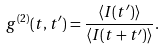Convert formula to latex. <formula><loc_0><loc_0><loc_500><loc_500>g ^ { ( 2 ) } ( t , t ^ { \prime } ) = \frac { \left \langle I ( t ^ { \prime } ) \right \rangle } { \left \langle I ( t + t ^ { \prime } ) \right \rangle } .</formula> 